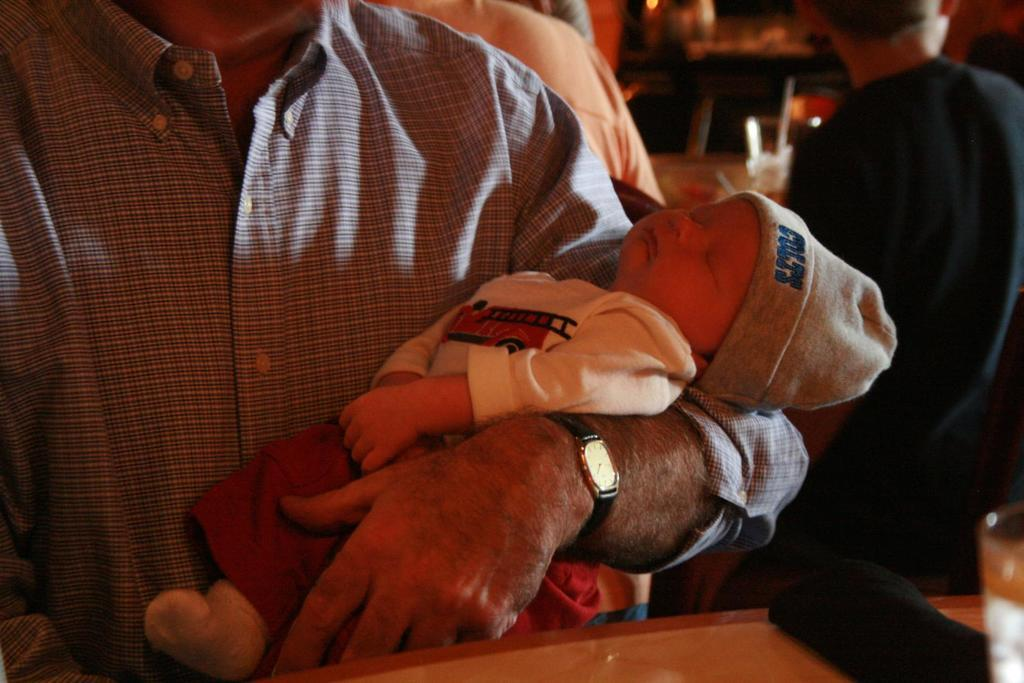<image>
Describe the image concisely. A newborn baby being held is wearing a COLTS hat on his head 